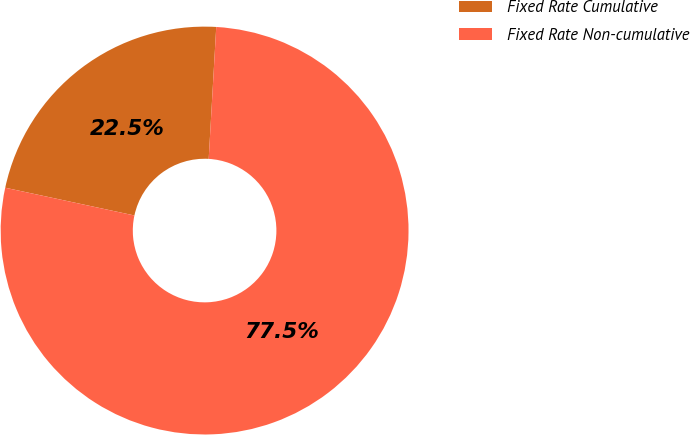<chart> <loc_0><loc_0><loc_500><loc_500><pie_chart><fcel>Fixed Rate Cumulative<fcel>Fixed Rate Non-cumulative<nl><fcel>22.54%<fcel>77.46%<nl></chart> 